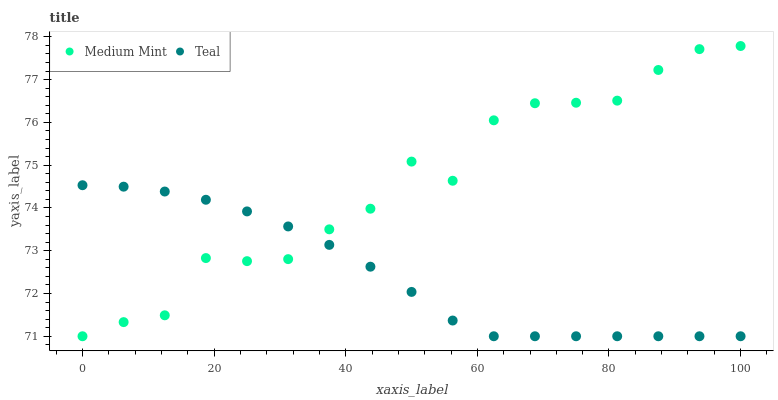Does Teal have the minimum area under the curve?
Answer yes or no. Yes. Does Medium Mint have the maximum area under the curve?
Answer yes or no. Yes. Does Teal have the maximum area under the curve?
Answer yes or no. No. Is Teal the smoothest?
Answer yes or no. Yes. Is Medium Mint the roughest?
Answer yes or no. Yes. Is Teal the roughest?
Answer yes or no. No. Does Medium Mint have the lowest value?
Answer yes or no. Yes. Does Medium Mint have the highest value?
Answer yes or no. Yes. Does Teal have the highest value?
Answer yes or no. No. Does Medium Mint intersect Teal?
Answer yes or no. Yes. Is Medium Mint less than Teal?
Answer yes or no. No. Is Medium Mint greater than Teal?
Answer yes or no. No. 